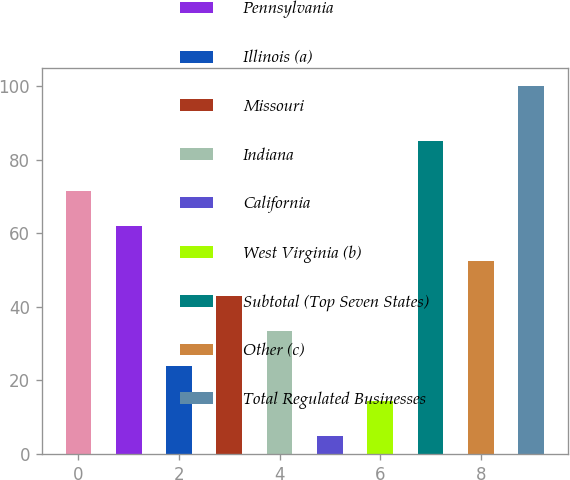Convert chart. <chart><loc_0><loc_0><loc_500><loc_500><bar_chart><fcel>New Jersey<fcel>Pennsylvania<fcel>Illinois (a)<fcel>Missouri<fcel>Indiana<fcel>California<fcel>West Virginia (b)<fcel>Subtotal (Top Seven States)<fcel>Other (c)<fcel>Total Regulated Businesses<nl><fcel>71.5<fcel>62<fcel>24<fcel>43<fcel>33.5<fcel>5<fcel>14.5<fcel>85.1<fcel>52.5<fcel>100<nl></chart> 